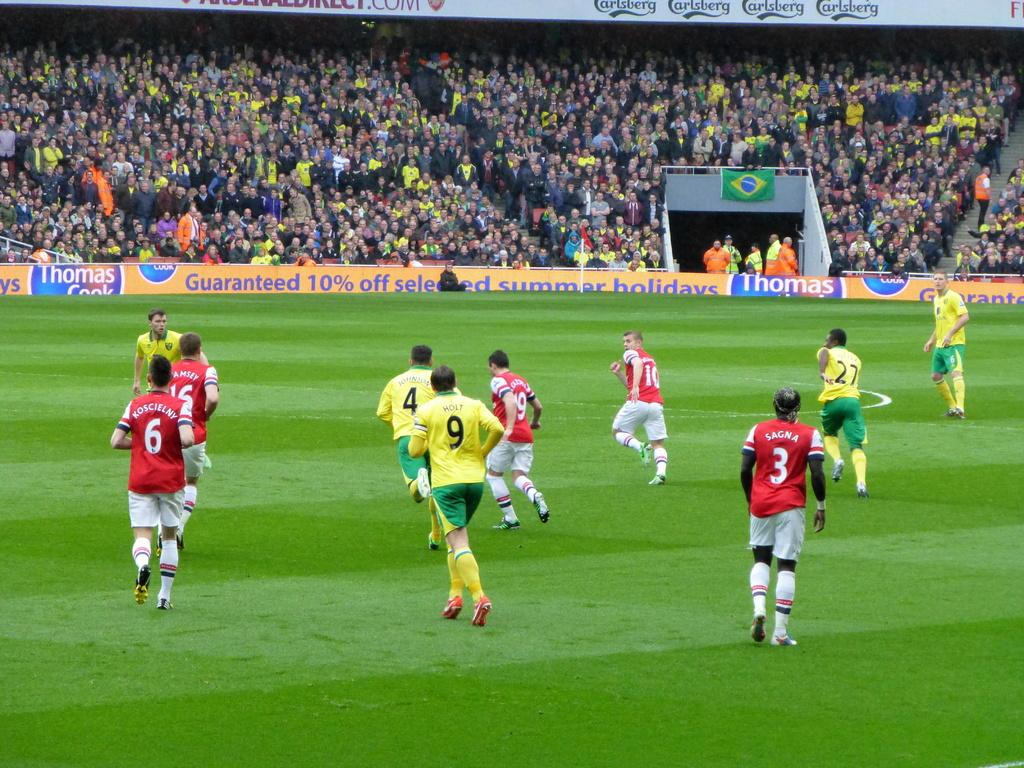<image>
Share a concise interpretation of the image provided. soccer match with banner on fence stating thomas cook guaranteed 10% off selected summer holidays 